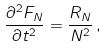Convert formula to latex. <formula><loc_0><loc_0><loc_500><loc_500>\frac { \partial ^ { 2 } F _ { N } } { \partial t ^ { 2 } } = \frac { R _ { N } } { N ^ { 2 } } \, ,</formula> 